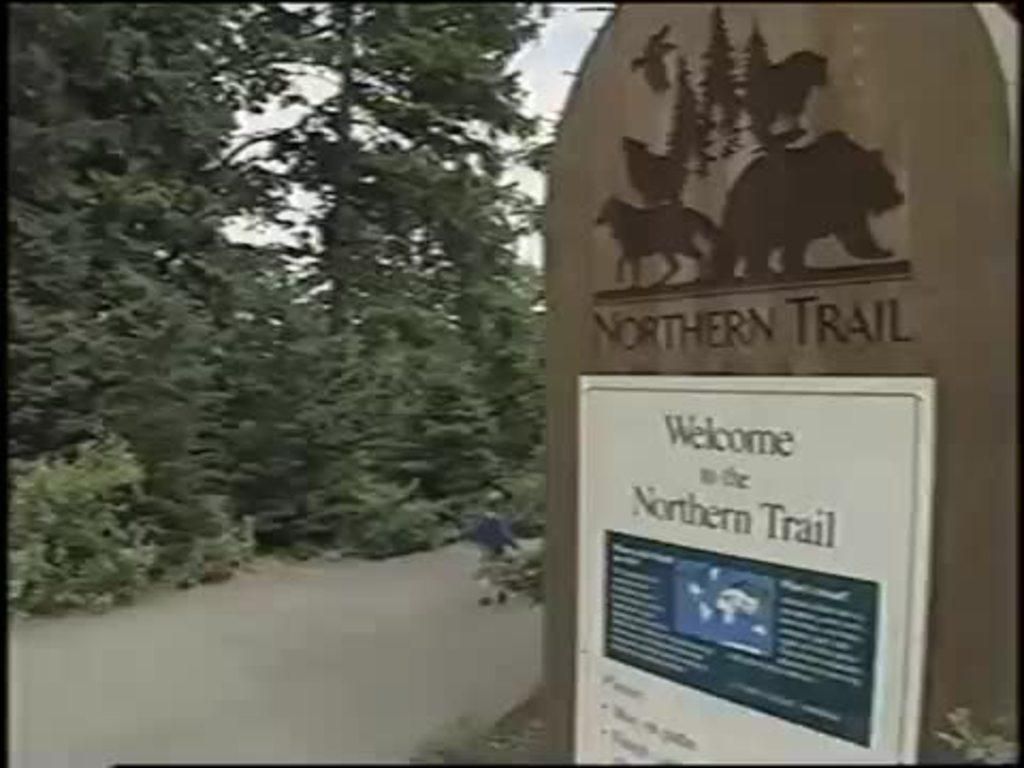<image>
Write a terse but informative summary of the picture. the words welcome to the northern trail that are on paper 